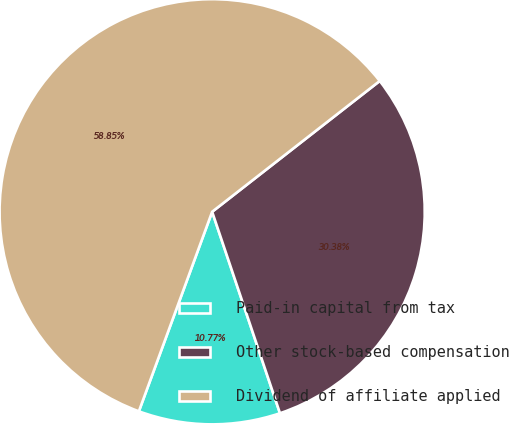<chart> <loc_0><loc_0><loc_500><loc_500><pie_chart><fcel>Paid-in capital from tax<fcel>Other stock-based compensation<fcel>Dividend of affiliate applied<nl><fcel>10.77%<fcel>30.38%<fcel>58.85%<nl></chart> 